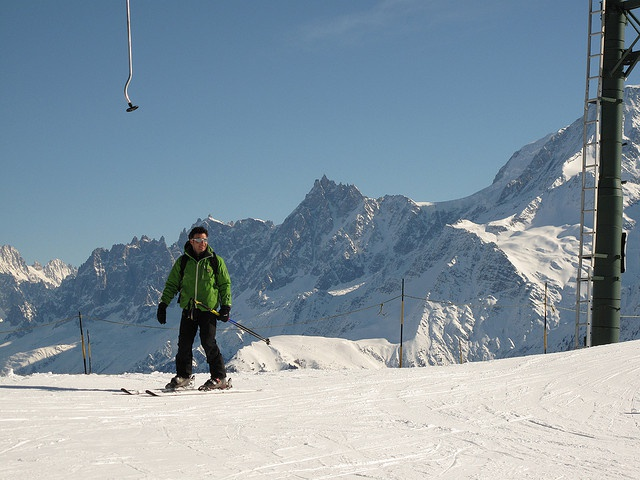Describe the objects in this image and their specific colors. I can see people in gray, black, and darkgreen tones and skis in gray, lightgray, and darkgray tones in this image. 